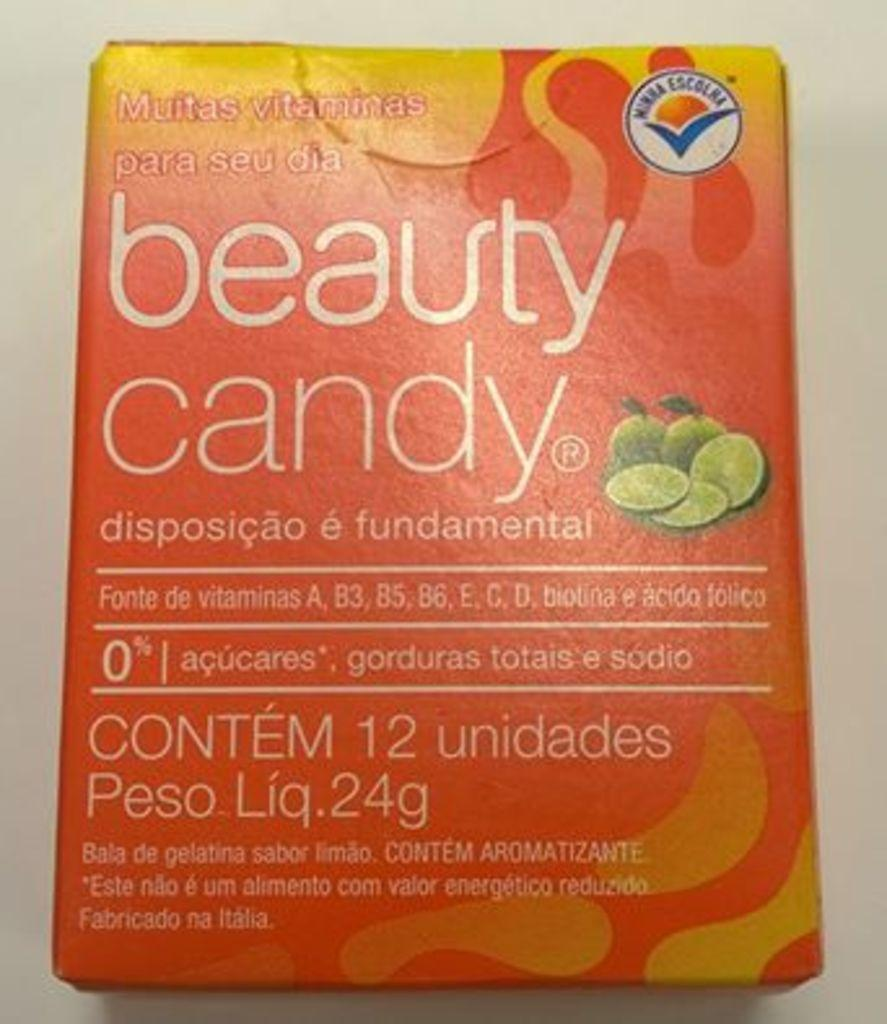What is present on the wall in the image? There is a poster in the image. What can be found on the poster? The poster contains images and text. What color is the surface behind the poster? The surface behind the poster is white. How many chances does the eye on the poster have to win a prize? There is no eye or mention of a prize on the poster in the image. 